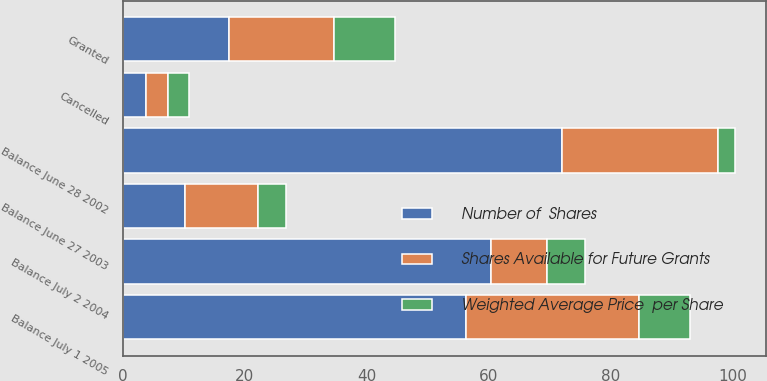Convert chart. <chart><loc_0><loc_0><loc_500><loc_500><stacked_bar_chart><ecel><fcel>Balance June 28 2002<fcel>Granted<fcel>Cancelled<fcel>Balance June 27 2003<fcel>Balance July 2 2004<fcel>Balance July 1 2005<nl><fcel>Number of  Shares<fcel>72<fcel>17.3<fcel>3.7<fcel>10.09<fcel>60.4<fcel>56.2<nl><fcel>Weighted Average Price  per Share<fcel>2.78<fcel>10.09<fcel>3.4<fcel>4.55<fcel>6.33<fcel>8.32<nl><fcel>Shares Available for Future Grants<fcel>25.7<fcel>17.3<fcel>3.7<fcel>12.1<fcel>9.1<fcel>28.5<nl></chart> 